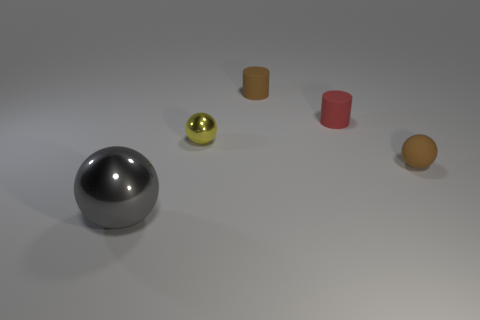Do the shiny ball that is on the right side of the large metal ball and the shiny thing that is in front of the small yellow thing have the same size?
Your answer should be very brief. No. What number of cylinders are either big blue things or large objects?
Your response must be concise. 0. What number of metal things are either small yellow objects or tiny objects?
Offer a terse response. 1. What is the size of the gray metallic object that is the same shape as the small yellow metal thing?
Offer a very short reply. Large. Is there any other thing that is the same size as the gray sphere?
Your answer should be compact. No. Is the size of the red matte object the same as the brown rubber object to the right of the tiny brown cylinder?
Your response must be concise. Yes. There is a brown thing to the right of the small brown cylinder; what is its shape?
Ensure brevity in your answer.  Sphere. There is a metal object that is in front of the tiny brown rubber thing that is in front of the red object; what is its color?
Your answer should be compact. Gray. What color is the other large metal thing that is the same shape as the yellow metal thing?
Keep it short and to the point. Gray. How many rubber cylinders are the same color as the large thing?
Your answer should be very brief. 0. 